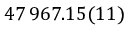Convert formula to latex. <formula><loc_0><loc_0><loc_500><loc_500>4 7 \, 9 6 7 . 1 5 ( 1 1 )</formula> 